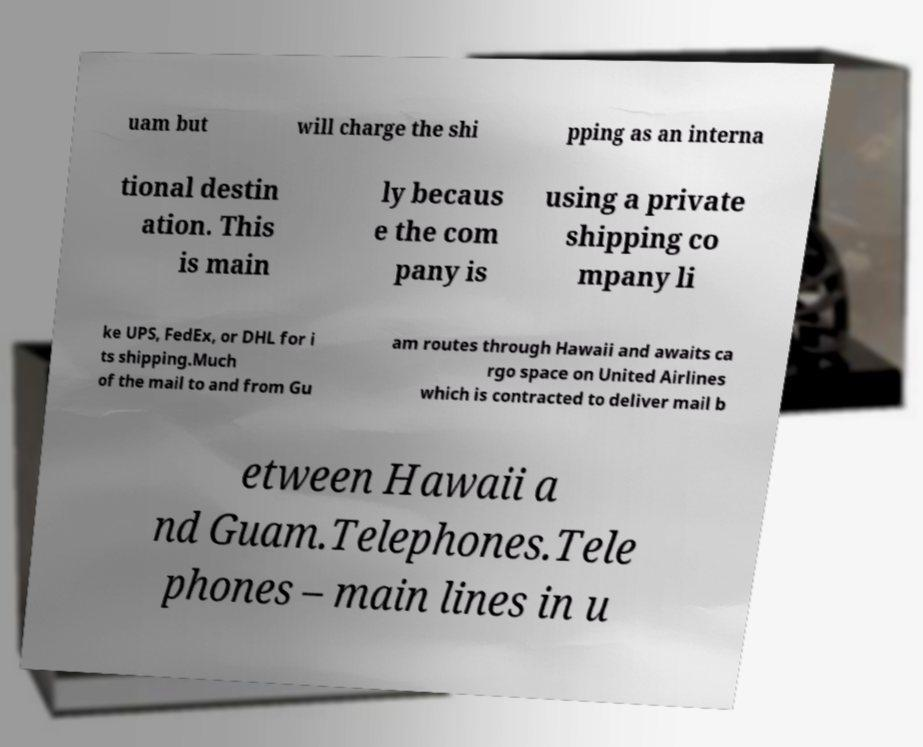What messages or text are displayed in this image? I need them in a readable, typed format. uam but will charge the shi pping as an interna tional destin ation. This is main ly becaus e the com pany is using a private shipping co mpany li ke UPS, FedEx, or DHL for i ts shipping.Much of the mail to and from Gu am routes through Hawaii and awaits ca rgo space on United Airlines which is contracted to deliver mail b etween Hawaii a nd Guam.Telephones.Tele phones – main lines in u 